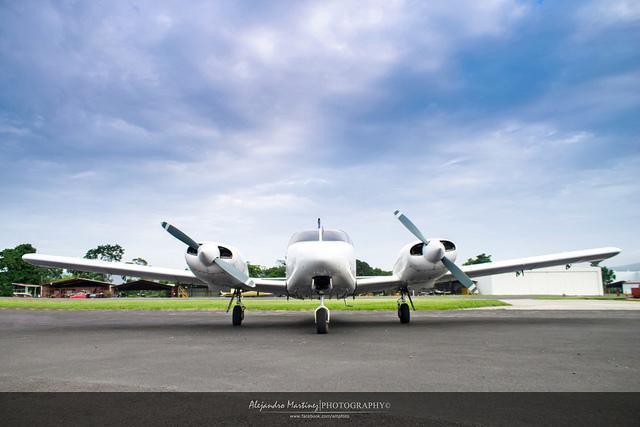How many hangars do you see?
Give a very brief answer. 1. How many men are wearing ties?
Give a very brief answer. 0. 